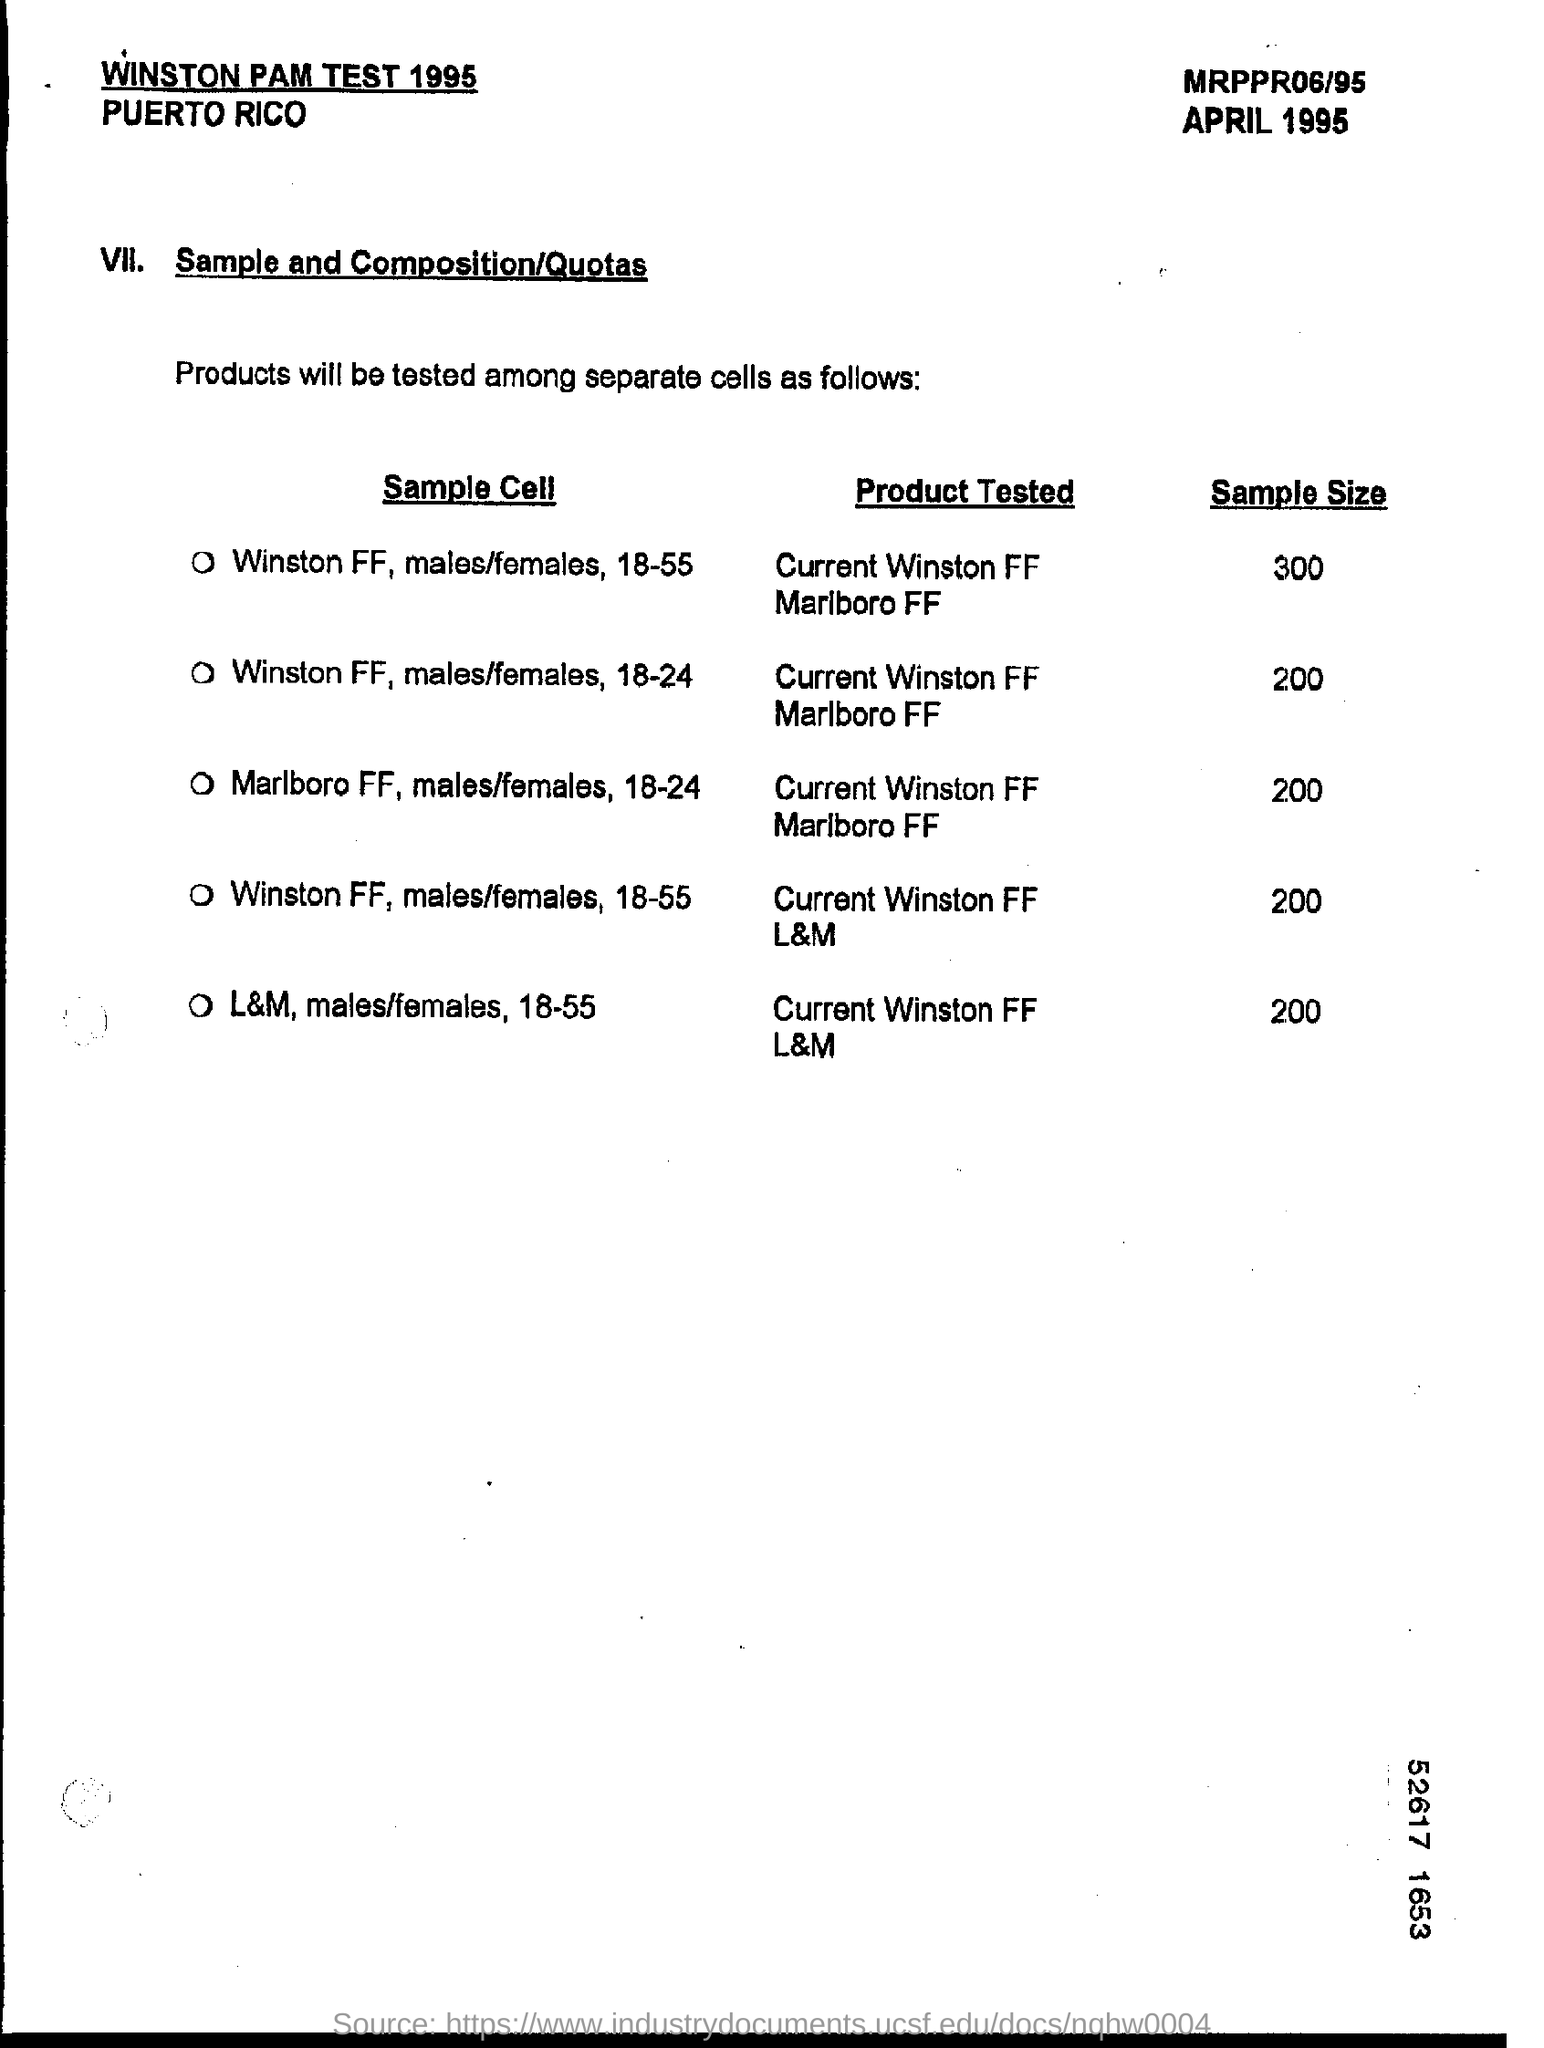Identify some key points in this picture. The sample size for the product tested was 200. 